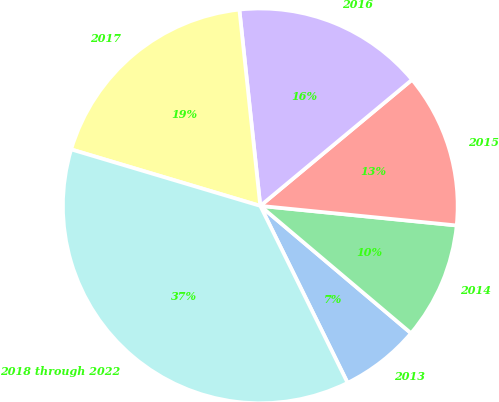<chart> <loc_0><loc_0><loc_500><loc_500><pie_chart><fcel>2013<fcel>2014<fcel>2015<fcel>2016<fcel>2017<fcel>2018 through 2022<nl><fcel>6.54%<fcel>9.58%<fcel>12.62%<fcel>15.65%<fcel>18.69%<fcel>36.91%<nl></chart> 